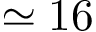<formula> <loc_0><loc_0><loc_500><loc_500>\simeq 1 6</formula> 